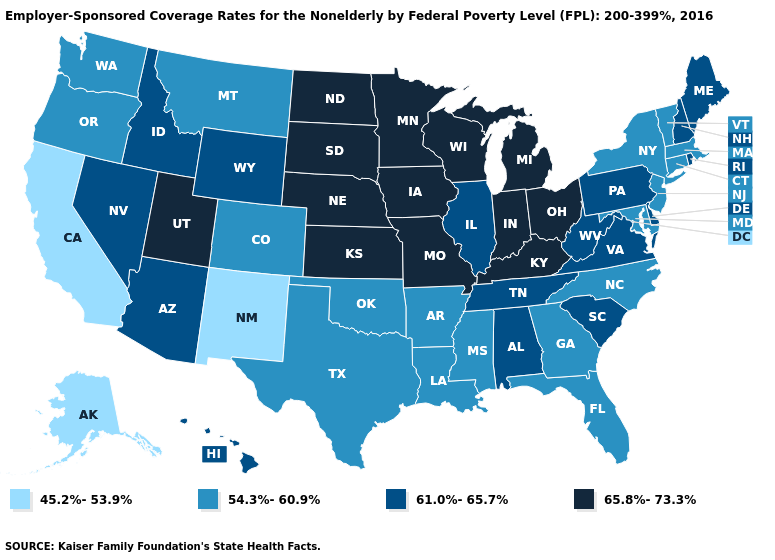What is the value of Nebraska?
Give a very brief answer. 65.8%-73.3%. What is the value of Indiana?
Give a very brief answer. 65.8%-73.3%. Name the states that have a value in the range 61.0%-65.7%?
Answer briefly. Alabama, Arizona, Delaware, Hawaii, Idaho, Illinois, Maine, Nevada, New Hampshire, Pennsylvania, Rhode Island, South Carolina, Tennessee, Virginia, West Virginia, Wyoming. What is the value of Wisconsin?
Answer briefly. 65.8%-73.3%. What is the highest value in the South ?
Answer briefly. 65.8%-73.3%. Does Virginia have the lowest value in the South?
Be succinct. No. What is the value of Texas?
Keep it brief. 54.3%-60.9%. What is the value of Connecticut?
Give a very brief answer. 54.3%-60.9%. What is the lowest value in the USA?
Give a very brief answer. 45.2%-53.9%. Which states have the lowest value in the MidWest?
Concise answer only. Illinois. Name the states that have a value in the range 61.0%-65.7%?
Answer briefly. Alabama, Arizona, Delaware, Hawaii, Idaho, Illinois, Maine, Nevada, New Hampshire, Pennsylvania, Rhode Island, South Carolina, Tennessee, Virginia, West Virginia, Wyoming. Among the states that border South Dakota , does Nebraska have the lowest value?
Quick response, please. No. What is the lowest value in the USA?
Quick response, please. 45.2%-53.9%. Which states have the highest value in the USA?
Concise answer only. Indiana, Iowa, Kansas, Kentucky, Michigan, Minnesota, Missouri, Nebraska, North Dakota, Ohio, South Dakota, Utah, Wisconsin. Does Maine have the lowest value in the Northeast?
Keep it brief. No. 